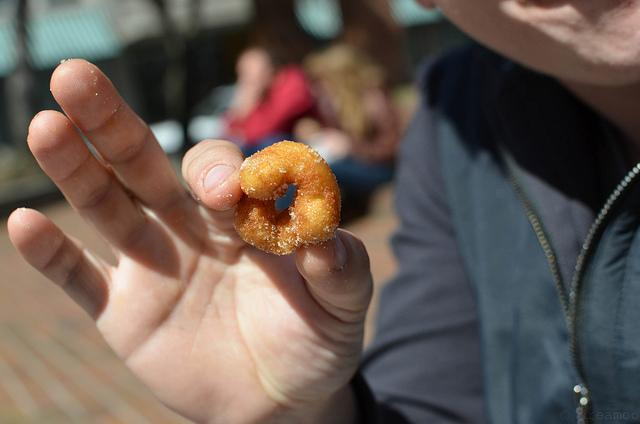What is the man holding?

Choices:
A) chicken ring
B) cinnamon roll
C) zeppole
D) calamari zeppole 